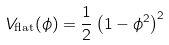Convert formula to latex. <formula><loc_0><loc_0><loc_500><loc_500>V _ { \text {flat} } ( \phi ) = \frac { 1 } { 2 } \left ( 1 - \phi ^ { 2 } \right ) ^ { 2 }</formula> 